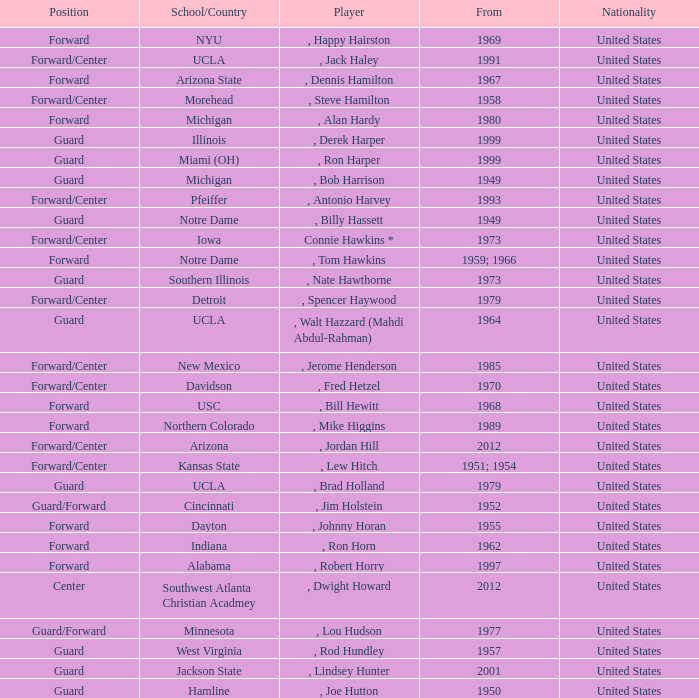Which school has the player that started in 1958? Morehead. 